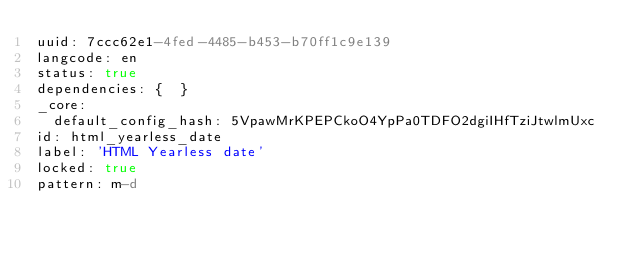<code> <loc_0><loc_0><loc_500><loc_500><_YAML_>uuid: 7ccc62e1-4fed-4485-b453-b70ff1c9e139
langcode: en
status: true
dependencies: {  }
_core:
  default_config_hash: 5VpawMrKPEPCkoO4YpPa0TDFO2dgiIHfTziJtwlmUxc
id: html_yearless_date
label: 'HTML Yearless date'
locked: true
pattern: m-d
</code> 